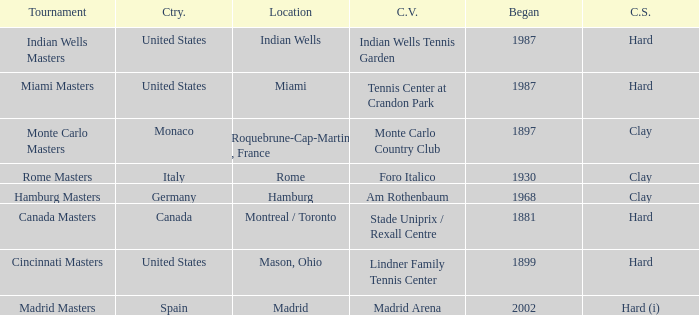I'm looking to parse the entire table for insights. Could you assist me with that? {'header': ['Tournament', 'Ctry.', 'Location', 'C.V.', 'Began', 'C.S.'], 'rows': [['Indian Wells Masters', 'United States', 'Indian Wells', 'Indian Wells Tennis Garden', '1987', 'Hard'], ['Miami Masters', 'United States', 'Miami', 'Tennis Center at Crandon Park', '1987', 'Hard'], ['Monte Carlo Masters', 'Monaco', 'Roquebrune-Cap-Martin , France', 'Monte Carlo Country Club', '1897', 'Clay'], ['Rome Masters', 'Italy', 'Rome', 'Foro Italico', '1930', 'Clay'], ['Hamburg Masters', 'Germany', 'Hamburg', 'Am Rothenbaum', '1968', 'Clay'], ['Canada Masters', 'Canada', 'Montreal / Toronto', 'Stade Uniprix / Rexall Centre', '1881', 'Hard'], ['Cincinnati Masters', 'United States', 'Mason, Ohio', 'Lindner Family Tennis Center', '1899', 'Hard'], ['Madrid Masters', 'Spain', 'Madrid', 'Madrid Arena', '2002', 'Hard (i)']]} Rome is in which country? Italy. 